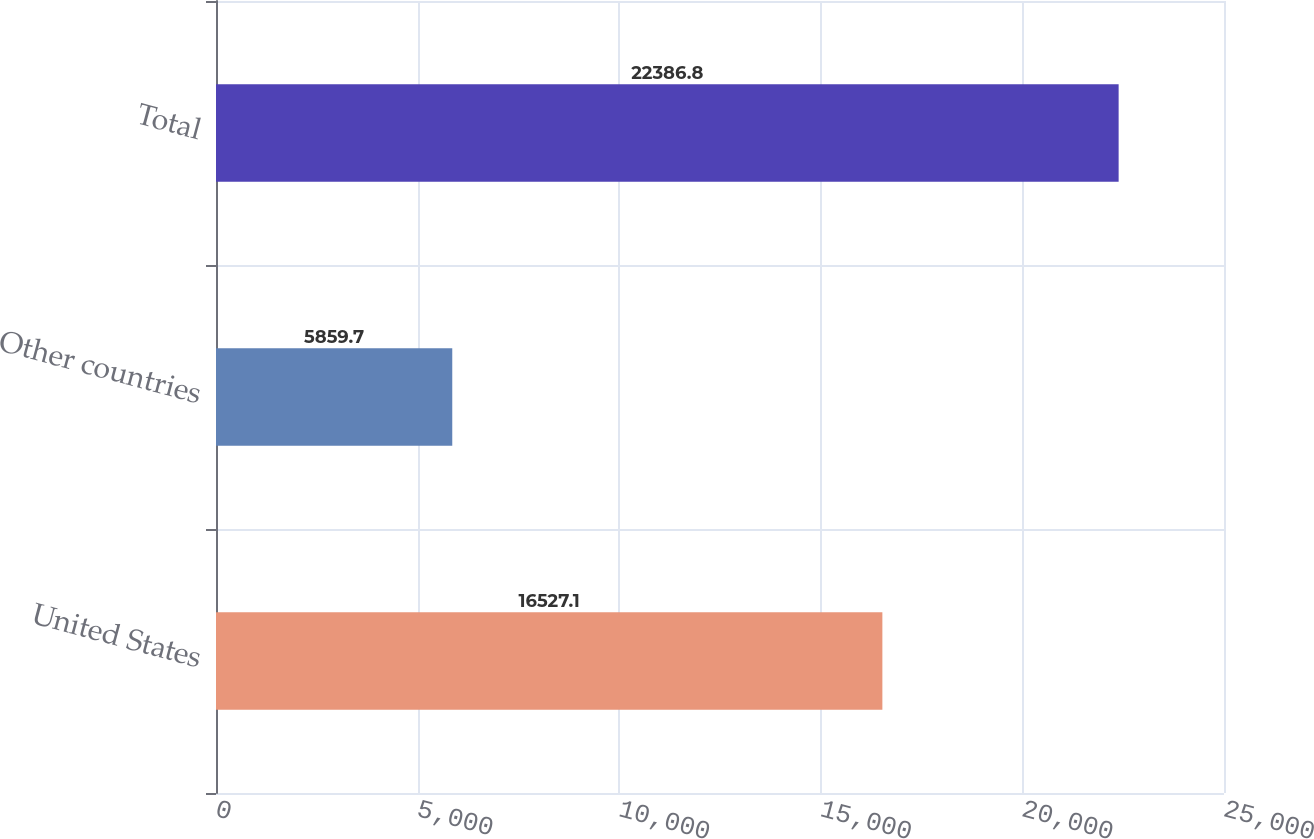<chart> <loc_0><loc_0><loc_500><loc_500><bar_chart><fcel>United States<fcel>Other countries<fcel>Total<nl><fcel>16527.1<fcel>5859.7<fcel>22386.8<nl></chart> 